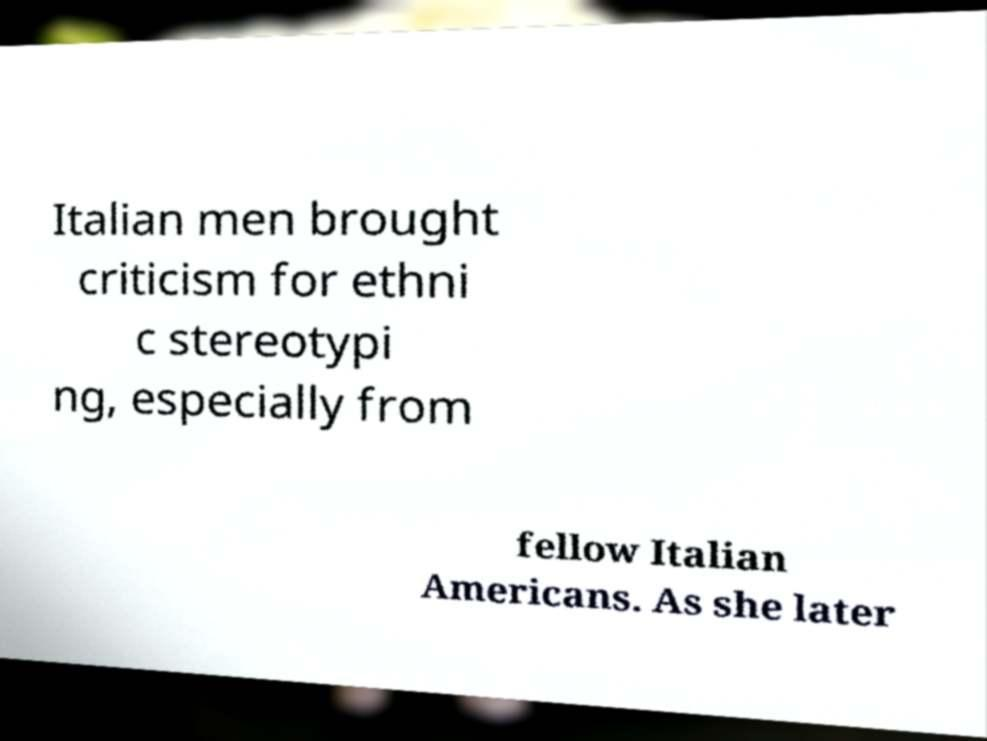There's text embedded in this image that I need extracted. Can you transcribe it verbatim? Italian men brought criticism for ethni c stereotypi ng, especially from fellow Italian Americans. As she later 